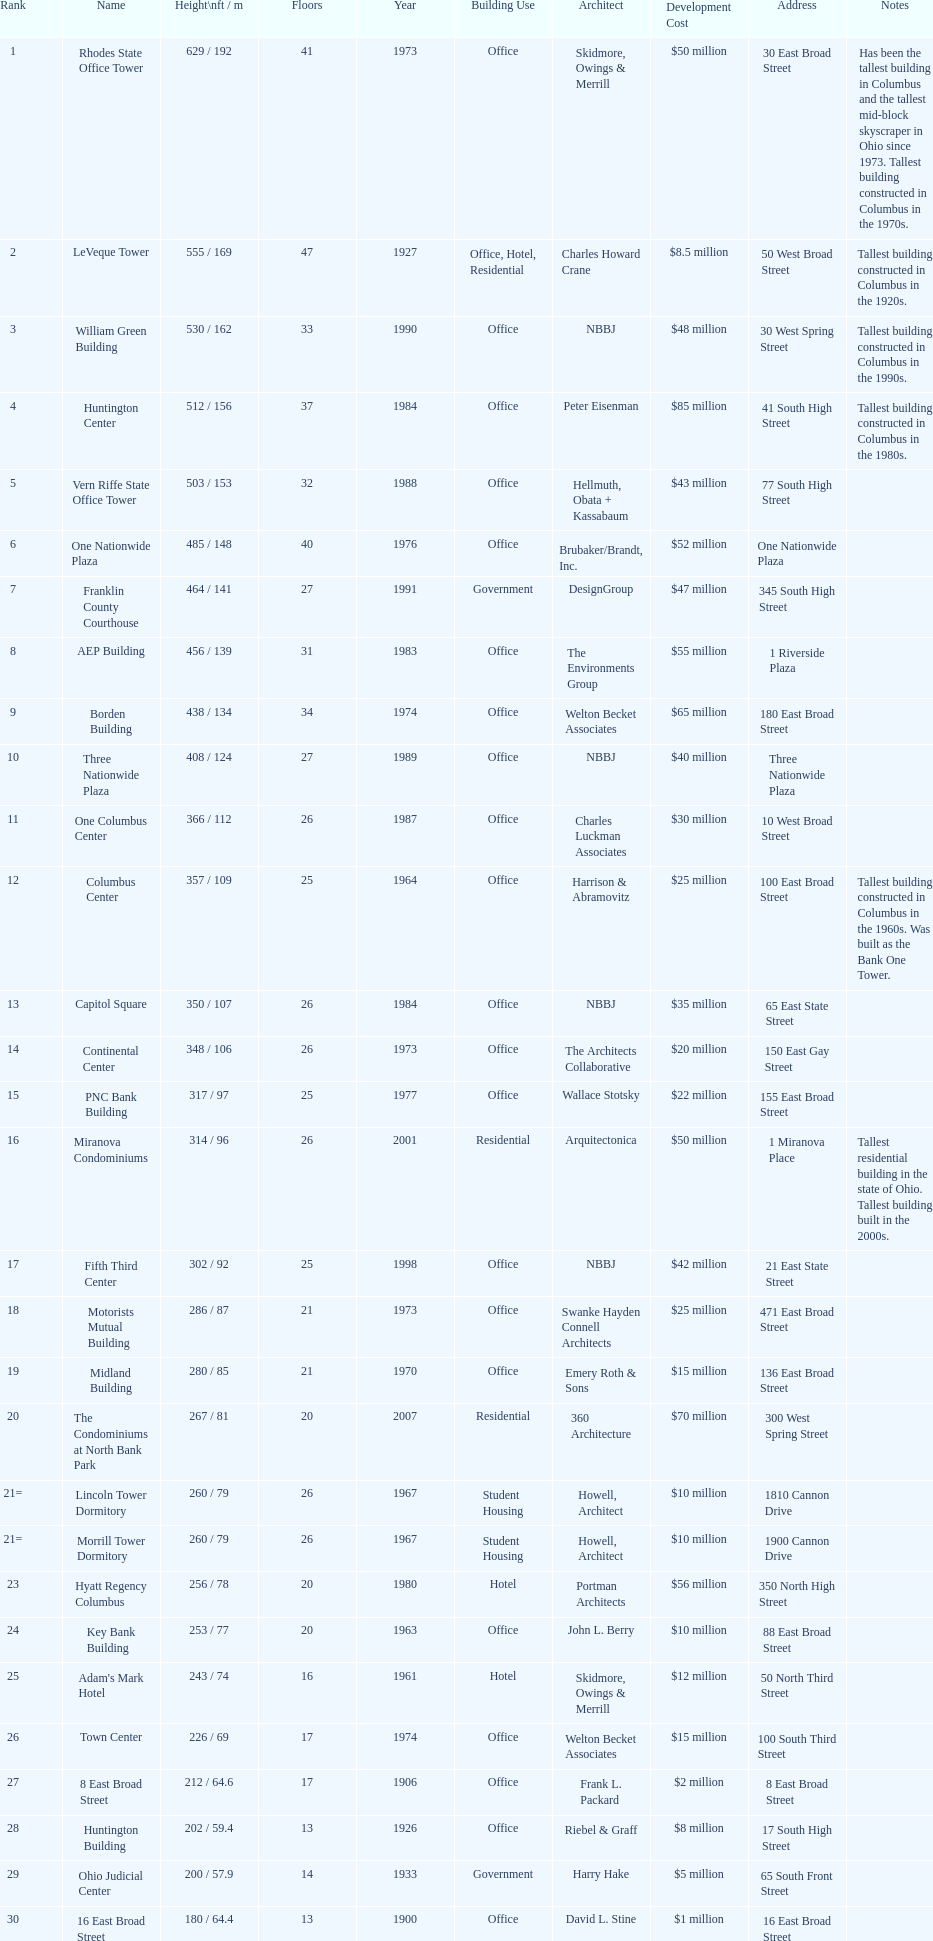What number of floors does the leveque tower have? 47. 